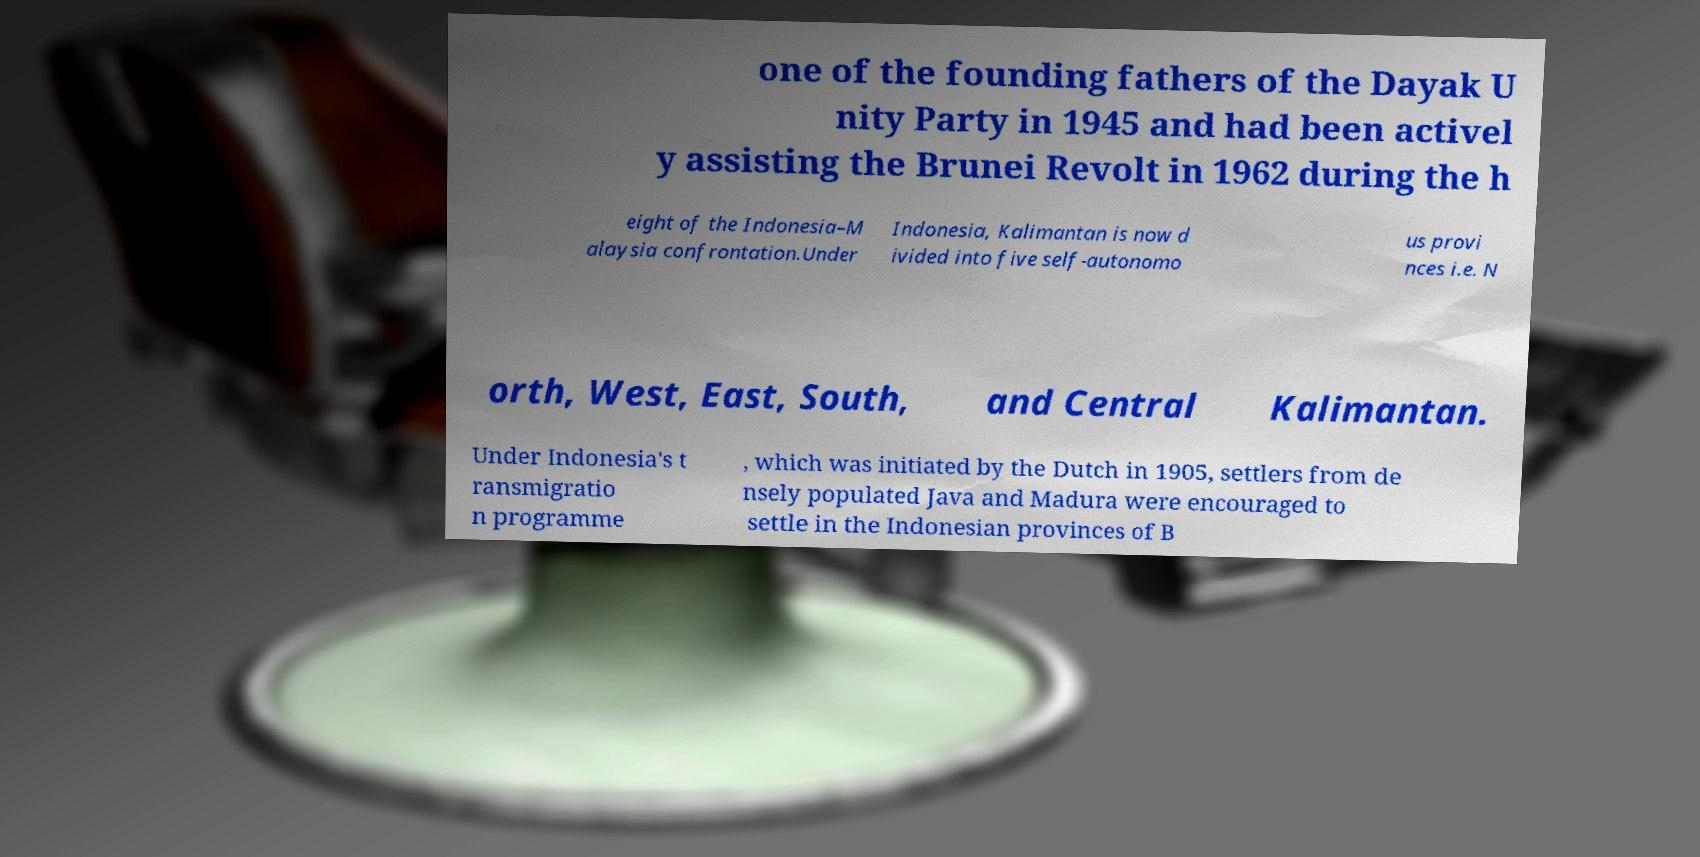Please identify and transcribe the text found in this image. one of the founding fathers of the Dayak U nity Party in 1945 and had been activel y assisting the Brunei Revolt in 1962 during the h eight of the Indonesia–M alaysia confrontation.Under Indonesia, Kalimantan is now d ivided into five self-autonomo us provi nces i.e. N orth, West, East, South, and Central Kalimantan. Under Indonesia's t ransmigratio n programme , which was initiated by the Dutch in 1905, settlers from de nsely populated Java and Madura were encouraged to settle in the Indonesian provinces of B 